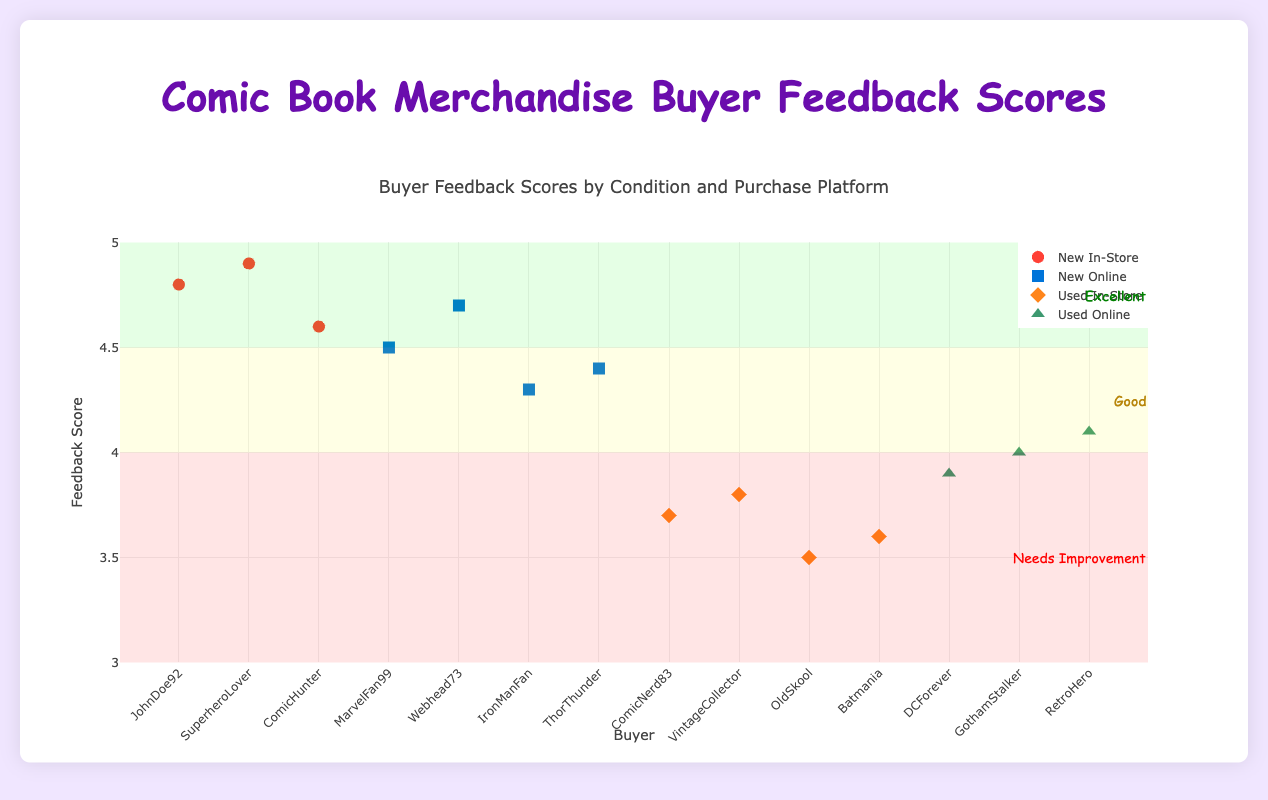What's the title of the figure? The title is displayed at the top center of the plot area in large, colorful text. It provides a quick reference to understand what the figure represents.
Answer: Comic Book Merchandise Buyer Feedback Scores How many data points are there for New condition merchandise purchased Online? In the legend, "New Online" group is represented by blue square markers. By counting these markers on the plot, you can determine the number of data points.
Answer: 5 Which category has the highest average feedback score: New In-Store or Used Online? By calculating the average feedback score for each category:
1. New In-Store: (4.8 + 4.9 + 4.6) / 3 = 4.77
2. Used Online: (3.9 + 4.0 + 4.1) / 3 = 4.0
Compare the averages to determine which is higher.
Answer: New In-Store Who is the buyer with the lowest feedback score for Used merchandise purchased In-Store? By identifying the Used In-Store category, which is represented by orange diamond markers, you can check the feedback scores of these points to find the lowest one.
Answer: OldSkool What is the range of feedback scores for New merchandise purchased Online? Identify the minimum and maximum values of the feedback scores for the blue square markers representing "New Online" group:
  min: 4.3
  max: 4.7
Then, calculate the range = max - min = 4.7 - 4.3.
Answer: 0.4 Compare the feedback scores for New merchandise purchased In-Store vs. Online. Which has the higher median score? List the scores for both categories:
1. New In-Store: 4.8, 4.9, 4.6
2. New Online: 4.3, 4.4, 4.5, 4.7
Calculate the medians:
New In-Store = 4.8
New Online = (4.4 + 4.5) / 2 = 4.45
Compare the medians.
Answer: New In-Store What percentage of New merchandise purchases in-store received a feedback score of 4.8 or higher? For New In-Store (4.8, 4.9, 4.6):
Calculate the percentage of scores that are 4.8 or higher:
Count = 2, Total = 3, (2 / 3) * 100 = 66.67%.
Answer: 66.67% What is the difference in average feedback scores between Used merchandise purchased Online and In-Store? Calculate average for both categories:
1. Used Online: (3.9 + 4.0 + 4.1) / 3 = 4.0
2. Used In-Store: (3.7 + 3.8 + 3.5 + 3.6) / 4 = 3.65
Difference = 4.0 - 3.65 = 0.35.
Answer: 0.35 Which group has a more consistent feedback score, Used Online or Used In-Store? Calculate the standard deviation for both groups to determine consistency:
1. Used Online: 3.9, 4.0, 4.1 (Std Dev = 0.0816)
2. Used In-Store: 3.7, 3.8, 3.5, 3.6 (Std Dev = 0.1291)
Lower standard deviation indicates higher consistency.
Answer: Used Online 